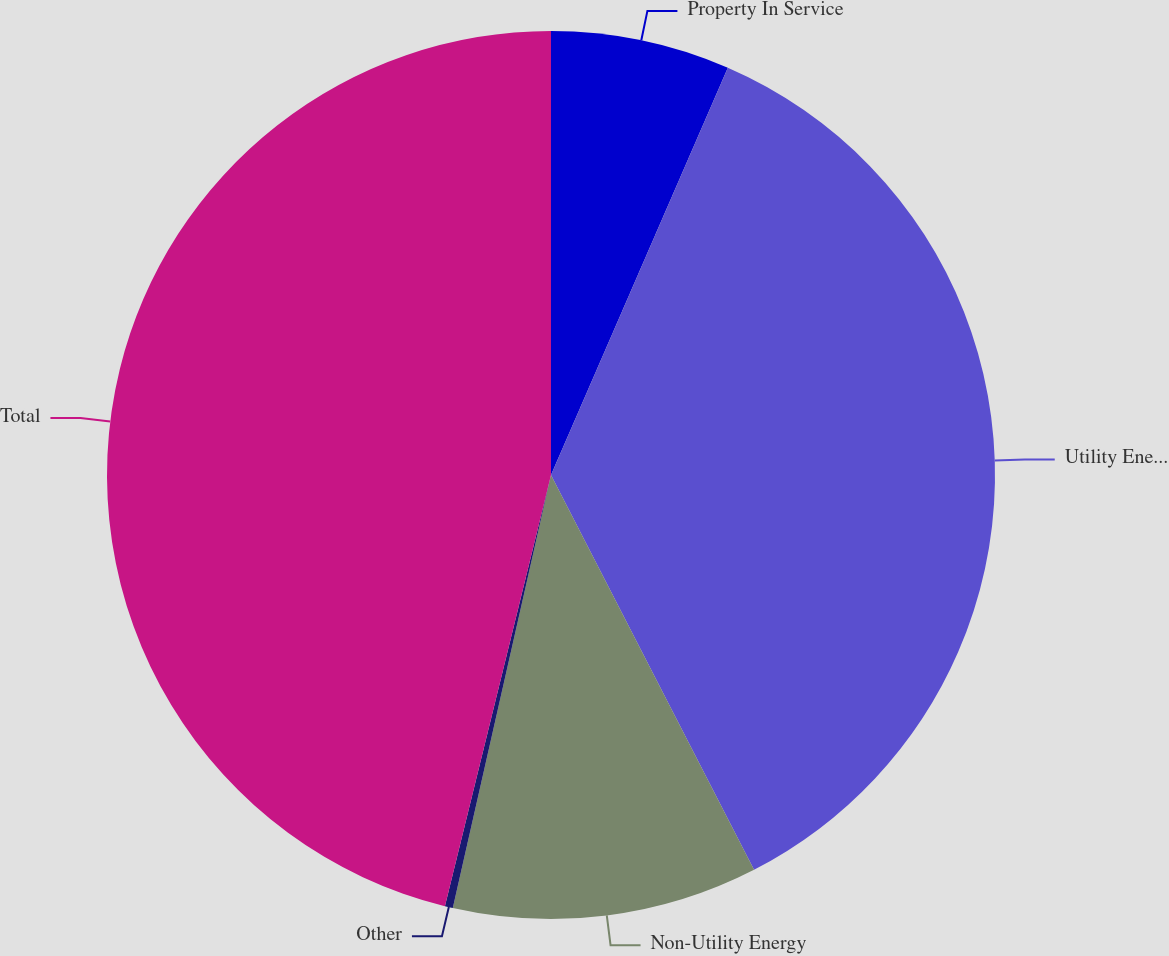Convert chart to OTSL. <chart><loc_0><loc_0><loc_500><loc_500><pie_chart><fcel>Property In Service<fcel>Utility Energy<fcel>Non-Utility Energy<fcel>Other<fcel>Total<nl><fcel>6.52%<fcel>35.92%<fcel>11.11%<fcel>0.29%<fcel>46.16%<nl></chart> 